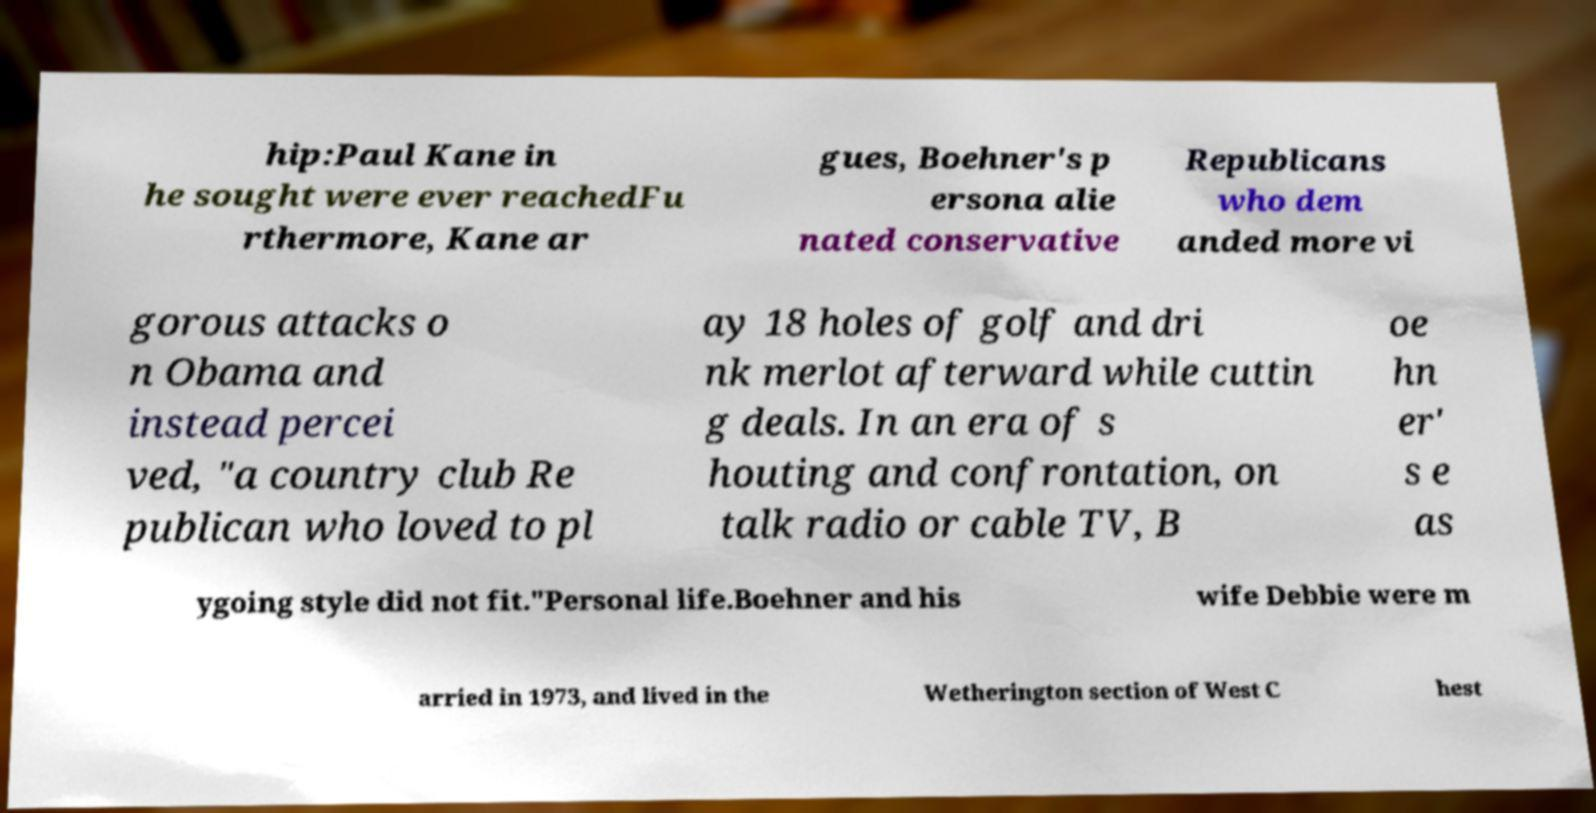Could you extract and type out the text from this image? hip:Paul Kane in he sought were ever reachedFu rthermore, Kane ar gues, Boehner's p ersona alie nated conservative Republicans who dem anded more vi gorous attacks o n Obama and instead percei ved, "a country club Re publican who loved to pl ay 18 holes of golf and dri nk merlot afterward while cuttin g deals. In an era of s houting and confrontation, on talk radio or cable TV, B oe hn er' s e as ygoing style did not fit."Personal life.Boehner and his wife Debbie were m arried in 1973, and lived in the Wetherington section of West C hest 